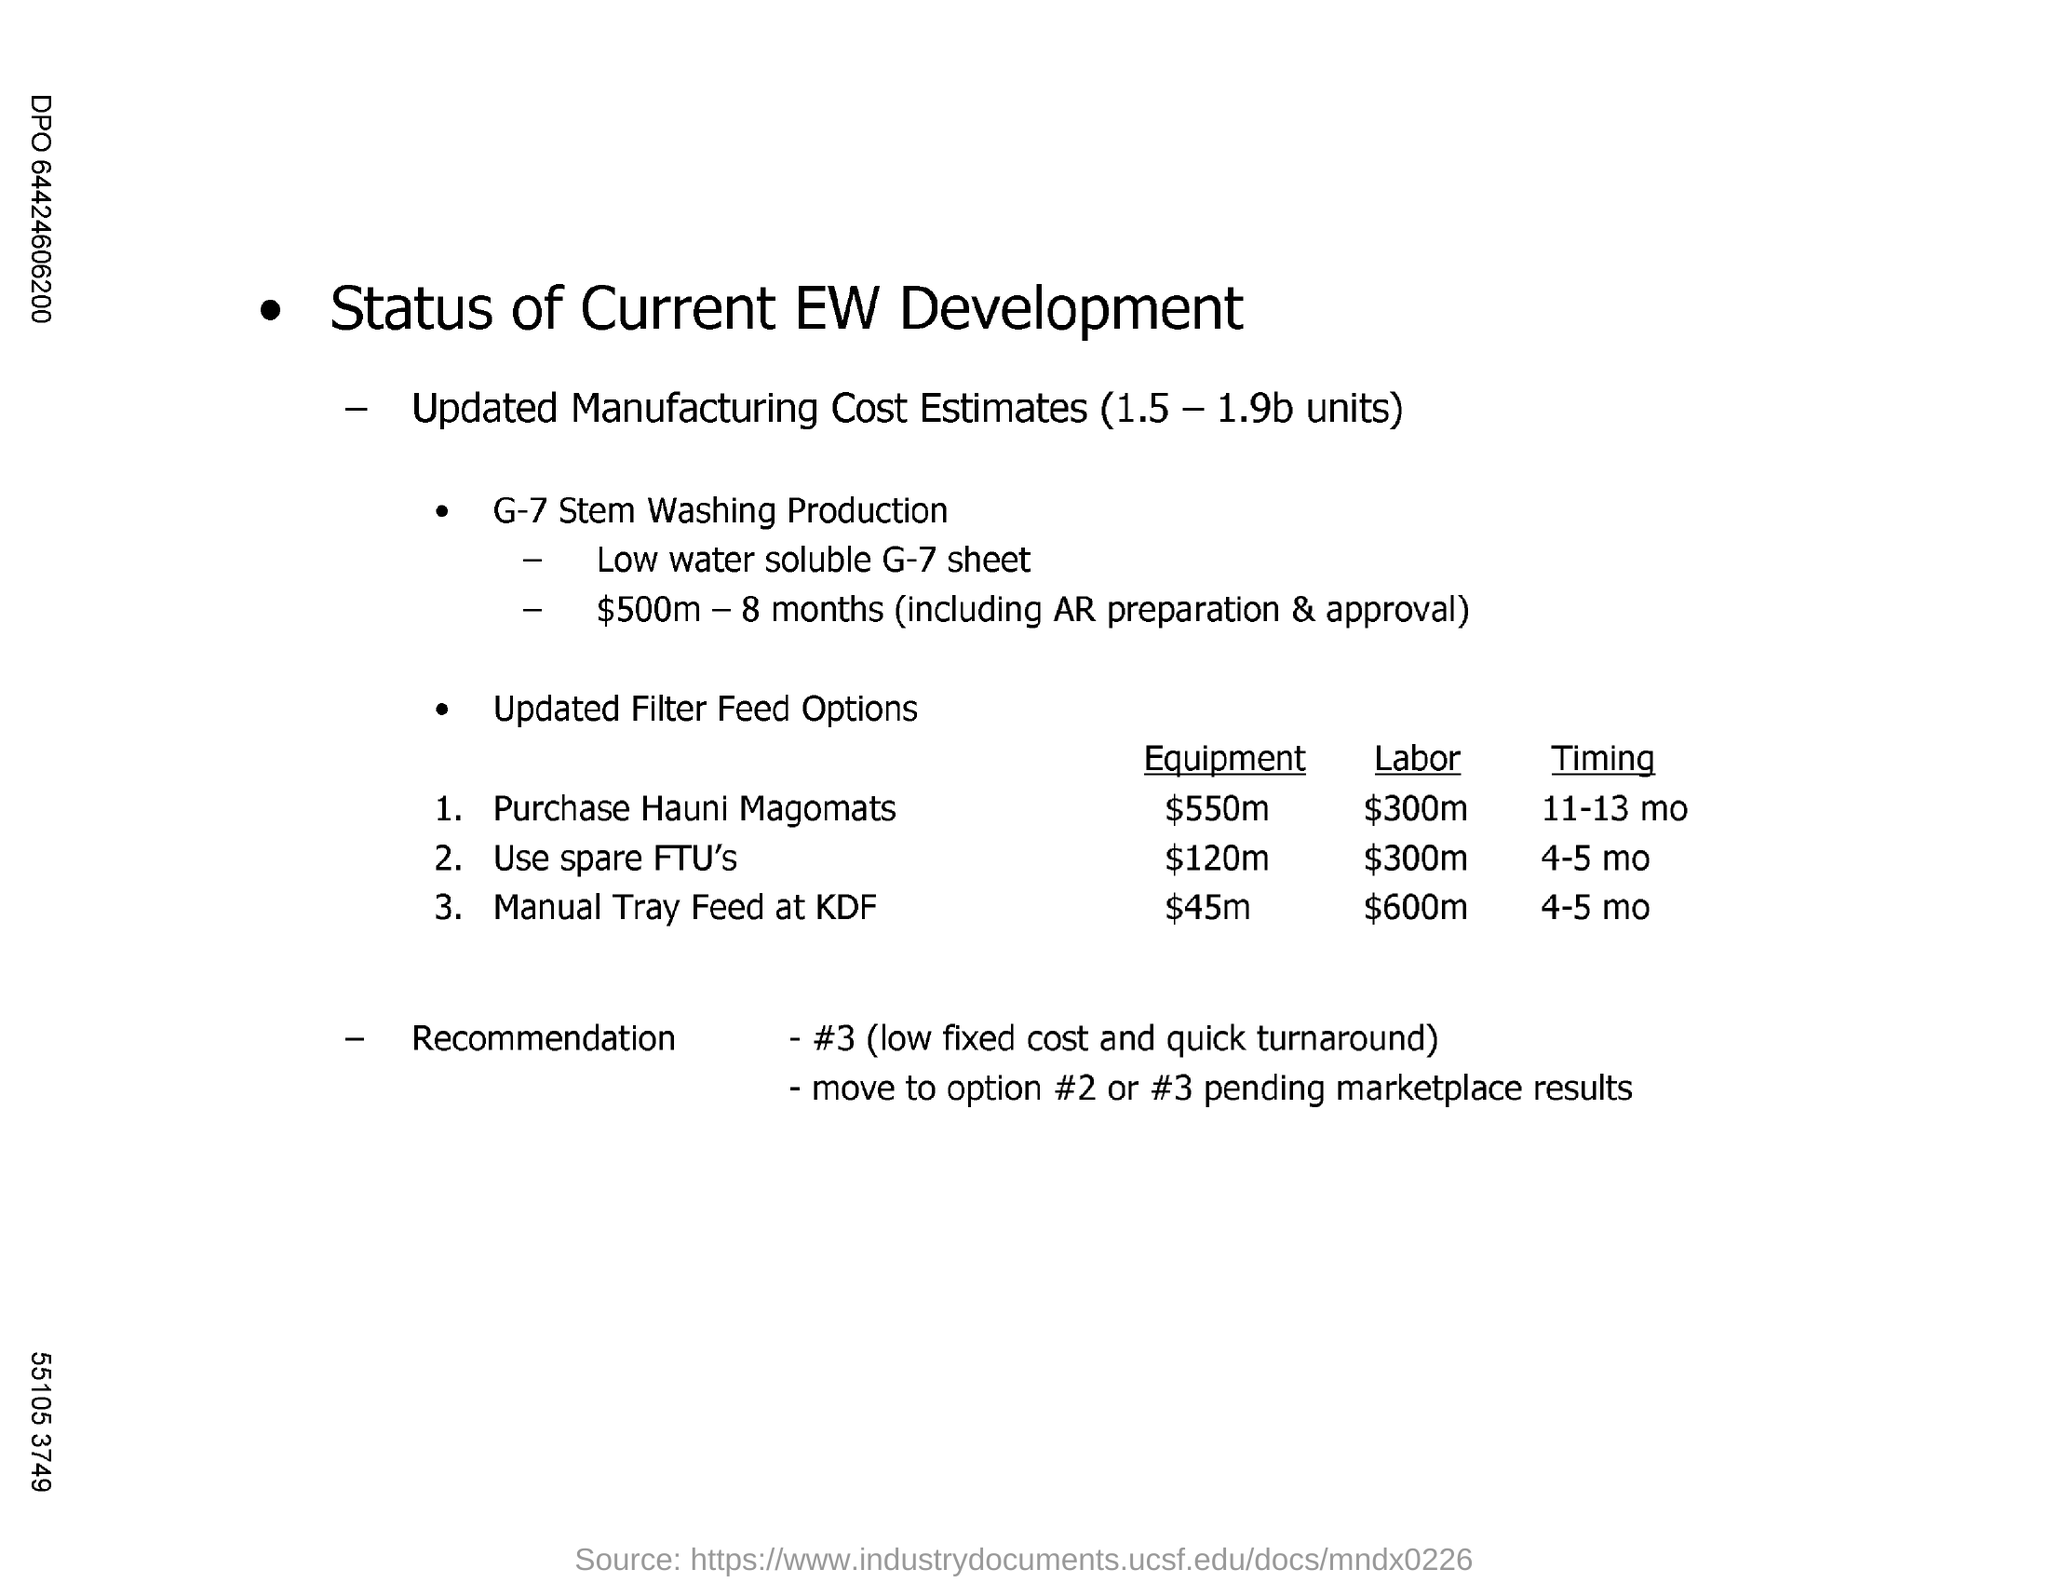Which filter feed option has the highest labor charge?
Your response must be concise. Manual Tray Feed at KDF. What is the timing of Purchase Hauni Magomats?
Make the answer very short. 11-13 mo. 